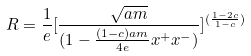<formula> <loc_0><loc_0><loc_500><loc_500>R = { \frac { 1 } { e } } [ { \frac { \sqrt { a m } } { ( 1 - { \frac { ( 1 - c ) a m } { 4 e } } x ^ { + } x ^ { - } ) } } ] ^ { ( { \frac { 1 - 2 c } { 1 - c } } ) }</formula> 